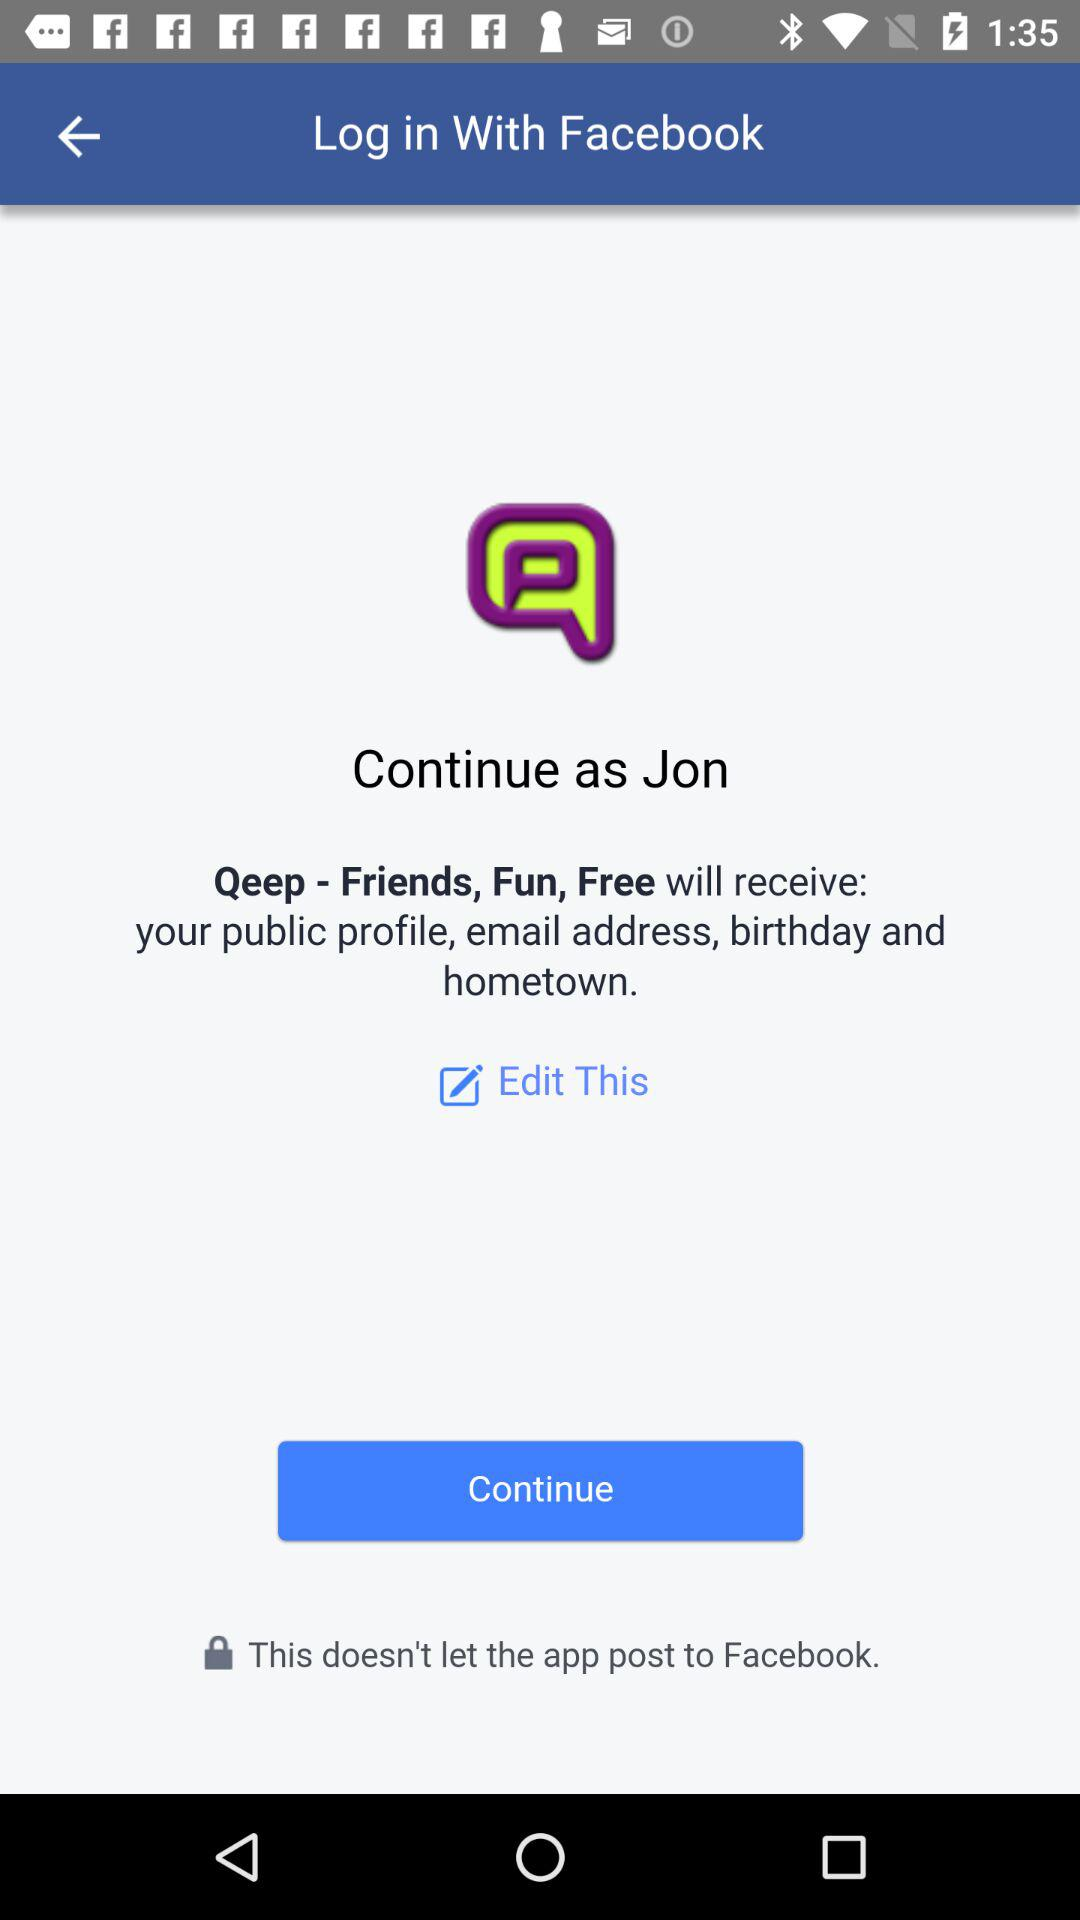What is the name of the user? The name of the user is Jon. 